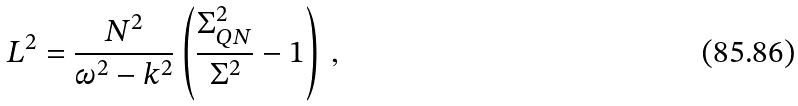<formula> <loc_0><loc_0><loc_500><loc_500>L ^ { 2 } = \frac { N ^ { 2 } } { \omega ^ { 2 } - k ^ { 2 } } \left ( \frac { \Sigma _ { Q N } ^ { 2 } } { \Sigma ^ { 2 } } - 1 \right ) \, ,</formula> 